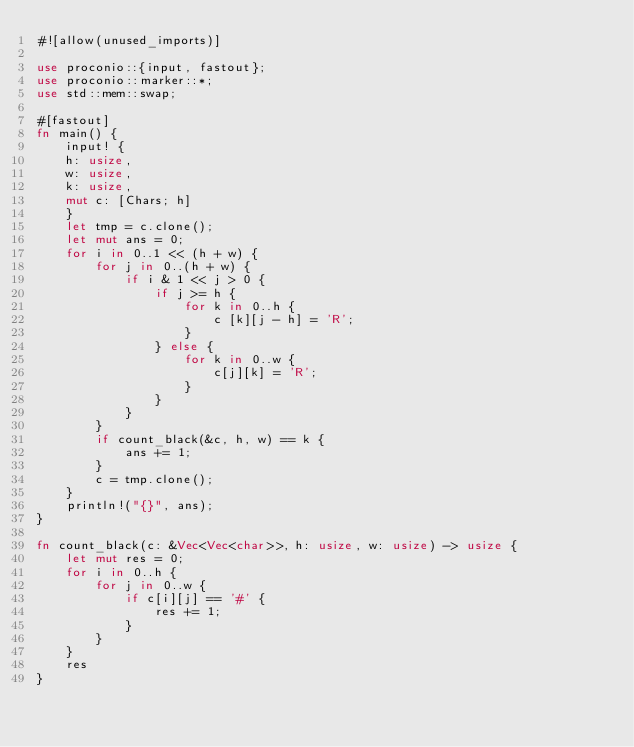Convert code to text. <code><loc_0><loc_0><loc_500><loc_500><_Rust_>#![allow(unused_imports)]

use proconio::{input, fastout};
use proconio::marker::*;
use std::mem::swap;

#[fastout]
fn main() {
    input! {
    h: usize,
    w: usize,
    k: usize,
    mut c: [Chars; h]
    }
    let tmp = c.clone();
    let mut ans = 0;
    for i in 0..1 << (h + w) {
        for j in 0..(h + w) {
            if i & 1 << j > 0 {
                if j >= h {
                    for k in 0..h {
                        c [k][j - h] = 'R';
                    }
                } else {
                    for k in 0..w {
                        c[j][k] = 'R';
                    }
                }
            }
        }
        if count_black(&c, h, w) == k {
            ans += 1;
        }
        c = tmp.clone();
    }
    println!("{}", ans);
}

fn count_black(c: &Vec<Vec<char>>, h: usize, w: usize) -> usize {
    let mut res = 0;
    for i in 0..h {
        for j in 0..w {
            if c[i][j] == '#' {
                res += 1;
            }
        }
    }
    res
}
</code> 